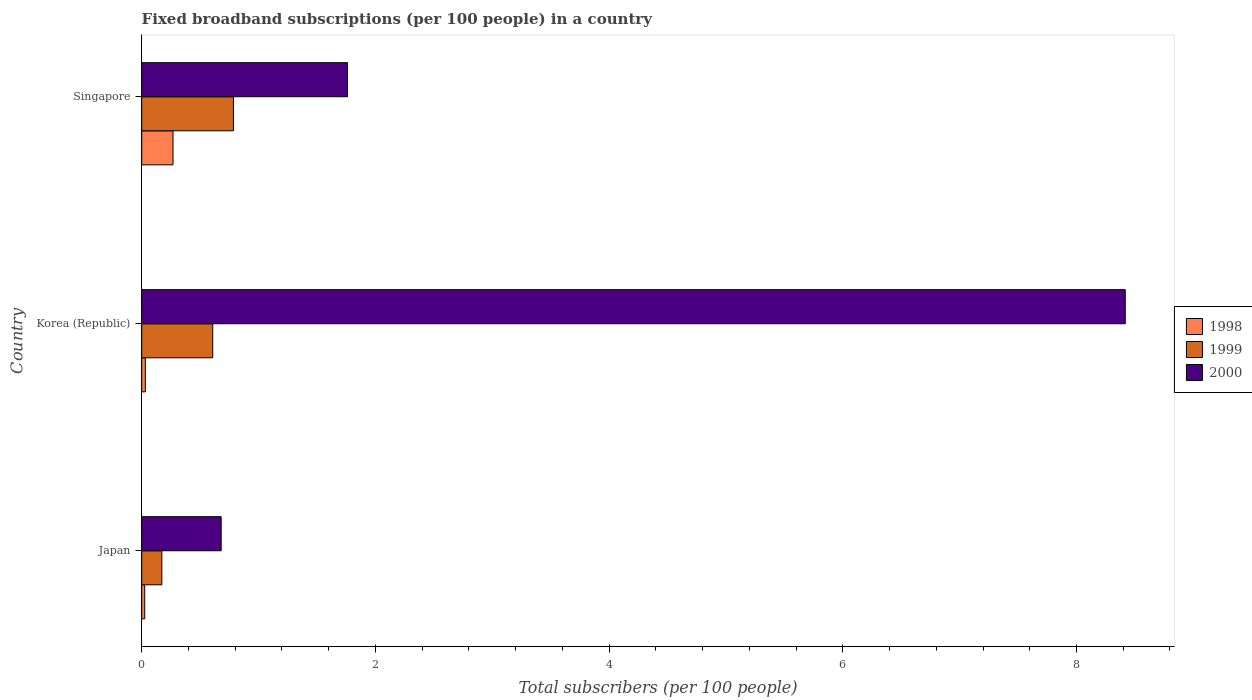How many bars are there on the 3rd tick from the bottom?
Your answer should be very brief. 3. What is the number of broadband subscriptions in 2000 in Japan?
Keep it short and to the point. 0.68. Across all countries, what is the maximum number of broadband subscriptions in 1999?
Your answer should be compact. 0.78. Across all countries, what is the minimum number of broadband subscriptions in 1999?
Make the answer very short. 0.17. In which country was the number of broadband subscriptions in 1998 maximum?
Offer a very short reply. Singapore. In which country was the number of broadband subscriptions in 1999 minimum?
Ensure brevity in your answer.  Japan. What is the total number of broadband subscriptions in 2000 in the graph?
Offer a very short reply. 10.86. What is the difference between the number of broadband subscriptions in 1999 in Korea (Republic) and that in Singapore?
Your response must be concise. -0.18. What is the difference between the number of broadband subscriptions in 2000 in Japan and the number of broadband subscriptions in 1998 in Korea (Republic)?
Give a very brief answer. 0.65. What is the average number of broadband subscriptions in 1999 per country?
Keep it short and to the point. 0.52. What is the difference between the number of broadband subscriptions in 1999 and number of broadband subscriptions in 1998 in Korea (Republic)?
Your answer should be very brief. 0.58. In how many countries, is the number of broadband subscriptions in 1999 greater than 6.8 ?
Your answer should be very brief. 0. What is the ratio of the number of broadband subscriptions in 2000 in Japan to that in Korea (Republic)?
Your answer should be compact. 0.08. Is the number of broadband subscriptions in 1999 in Korea (Republic) less than that in Singapore?
Make the answer very short. Yes. What is the difference between the highest and the second highest number of broadband subscriptions in 1999?
Give a very brief answer. 0.18. What is the difference between the highest and the lowest number of broadband subscriptions in 1998?
Your answer should be very brief. 0.24. Is the sum of the number of broadband subscriptions in 1998 in Korea (Republic) and Singapore greater than the maximum number of broadband subscriptions in 2000 across all countries?
Make the answer very short. No. Is it the case that in every country, the sum of the number of broadband subscriptions in 1999 and number of broadband subscriptions in 1998 is greater than the number of broadband subscriptions in 2000?
Your answer should be compact. No. How many bars are there?
Give a very brief answer. 9. What is the difference between two consecutive major ticks on the X-axis?
Offer a very short reply. 2. Does the graph contain any zero values?
Make the answer very short. No. Does the graph contain grids?
Provide a short and direct response. No. How many legend labels are there?
Your answer should be compact. 3. What is the title of the graph?
Your response must be concise. Fixed broadband subscriptions (per 100 people) in a country. What is the label or title of the X-axis?
Provide a succinct answer. Total subscribers (per 100 people). What is the label or title of the Y-axis?
Provide a succinct answer. Country. What is the Total subscribers (per 100 people) of 1998 in Japan?
Make the answer very short. 0.03. What is the Total subscribers (per 100 people) of 1999 in Japan?
Your response must be concise. 0.17. What is the Total subscribers (per 100 people) of 2000 in Japan?
Ensure brevity in your answer.  0.68. What is the Total subscribers (per 100 people) of 1998 in Korea (Republic)?
Your response must be concise. 0.03. What is the Total subscribers (per 100 people) in 1999 in Korea (Republic)?
Your answer should be very brief. 0.61. What is the Total subscribers (per 100 people) in 2000 in Korea (Republic)?
Give a very brief answer. 8.42. What is the Total subscribers (per 100 people) in 1998 in Singapore?
Give a very brief answer. 0.27. What is the Total subscribers (per 100 people) of 1999 in Singapore?
Your answer should be compact. 0.78. What is the Total subscribers (per 100 people) in 2000 in Singapore?
Keep it short and to the point. 1.76. Across all countries, what is the maximum Total subscribers (per 100 people) in 1998?
Offer a very short reply. 0.27. Across all countries, what is the maximum Total subscribers (per 100 people) in 1999?
Keep it short and to the point. 0.78. Across all countries, what is the maximum Total subscribers (per 100 people) of 2000?
Offer a very short reply. 8.42. Across all countries, what is the minimum Total subscribers (per 100 people) of 1998?
Offer a very short reply. 0.03. Across all countries, what is the minimum Total subscribers (per 100 people) in 1999?
Provide a short and direct response. 0.17. Across all countries, what is the minimum Total subscribers (per 100 people) in 2000?
Offer a terse response. 0.68. What is the total Total subscribers (per 100 people) in 1998 in the graph?
Ensure brevity in your answer.  0.32. What is the total Total subscribers (per 100 people) in 1999 in the graph?
Offer a terse response. 1.56. What is the total Total subscribers (per 100 people) in 2000 in the graph?
Offer a very short reply. 10.86. What is the difference between the Total subscribers (per 100 people) of 1998 in Japan and that in Korea (Republic)?
Give a very brief answer. -0.01. What is the difference between the Total subscribers (per 100 people) of 1999 in Japan and that in Korea (Republic)?
Keep it short and to the point. -0.44. What is the difference between the Total subscribers (per 100 people) in 2000 in Japan and that in Korea (Republic)?
Ensure brevity in your answer.  -7.74. What is the difference between the Total subscribers (per 100 people) in 1998 in Japan and that in Singapore?
Your answer should be very brief. -0.24. What is the difference between the Total subscribers (per 100 people) of 1999 in Japan and that in Singapore?
Provide a short and direct response. -0.61. What is the difference between the Total subscribers (per 100 people) in 2000 in Japan and that in Singapore?
Your answer should be compact. -1.08. What is the difference between the Total subscribers (per 100 people) of 1998 in Korea (Republic) and that in Singapore?
Offer a very short reply. -0.24. What is the difference between the Total subscribers (per 100 people) in 1999 in Korea (Republic) and that in Singapore?
Your answer should be very brief. -0.18. What is the difference between the Total subscribers (per 100 people) of 2000 in Korea (Republic) and that in Singapore?
Your response must be concise. 6.66. What is the difference between the Total subscribers (per 100 people) of 1998 in Japan and the Total subscribers (per 100 people) of 1999 in Korea (Republic)?
Make the answer very short. -0.58. What is the difference between the Total subscribers (per 100 people) in 1998 in Japan and the Total subscribers (per 100 people) in 2000 in Korea (Republic)?
Your response must be concise. -8.39. What is the difference between the Total subscribers (per 100 people) in 1999 in Japan and the Total subscribers (per 100 people) in 2000 in Korea (Republic)?
Make the answer very short. -8.25. What is the difference between the Total subscribers (per 100 people) in 1998 in Japan and the Total subscribers (per 100 people) in 1999 in Singapore?
Give a very brief answer. -0.76. What is the difference between the Total subscribers (per 100 people) of 1998 in Japan and the Total subscribers (per 100 people) of 2000 in Singapore?
Give a very brief answer. -1.74. What is the difference between the Total subscribers (per 100 people) in 1999 in Japan and the Total subscribers (per 100 people) in 2000 in Singapore?
Ensure brevity in your answer.  -1.59. What is the difference between the Total subscribers (per 100 people) in 1998 in Korea (Republic) and the Total subscribers (per 100 people) in 1999 in Singapore?
Your answer should be very brief. -0.75. What is the difference between the Total subscribers (per 100 people) in 1998 in Korea (Republic) and the Total subscribers (per 100 people) in 2000 in Singapore?
Provide a succinct answer. -1.73. What is the difference between the Total subscribers (per 100 people) in 1999 in Korea (Republic) and the Total subscribers (per 100 people) in 2000 in Singapore?
Make the answer very short. -1.15. What is the average Total subscribers (per 100 people) of 1998 per country?
Offer a terse response. 0.11. What is the average Total subscribers (per 100 people) of 1999 per country?
Make the answer very short. 0.52. What is the average Total subscribers (per 100 people) of 2000 per country?
Your answer should be compact. 3.62. What is the difference between the Total subscribers (per 100 people) in 1998 and Total subscribers (per 100 people) in 1999 in Japan?
Your response must be concise. -0.15. What is the difference between the Total subscribers (per 100 people) in 1998 and Total subscribers (per 100 people) in 2000 in Japan?
Your response must be concise. -0.65. What is the difference between the Total subscribers (per 100 people) of 1999 and Total subscribers (per 100 people) of 2000 in Japan?
Offer a terse response. -0.51. What is the difference between the Total subscribers (per 100 people) in 1998 and Total subscribers (per 100 people) in 1999 in Korea (Republic)?
Your answer should be compact. -0.58. What is the difference between the Total subscribers (per 100 people) in 1998 and Total subscribers (per 100 people) in 2000 in Korea (Republic)?
Your answer should be very brief. -8.39. What is the difference between the Total subscribers (per 100 people) in 1999 and Total subscribers (per 100 people) in 2000 in Korea (Republic)?
Give a very brief answer. -7.81. What is the difference between the Total subscribers (per 100 people) in 1998 and Total subscribers (per 100 people) in 1999 in Singapore?
Provide a short and direct response. -0.52. What is the difference between the Total subscribers (per 100 people) of 1998 and Total subscribers (per 100 people) of 2000 in Singapore?
Your answer should be compact. -1.49. What is the difference between the Total subscribers (per 100 people) in 1999 and Total subscribers (per 100 people) in 2000 in Singapore?
Keep it short and to the point. -0.98. What is the ratio of the Total subscribers (per 100 people) of 1998 in Japan to that in Korea (Republic)?
Offer a very short reply. 0.83. What is the ratio of the Total subscribers (per 100 people) of 1999 in Japan to that in Korea (Republic)?
Make the answer very short. 0.28. What is the ratio of the Total subscribers (per 100 people) in 2000 in Japan to that in Korea (Republic)?
Offer a terse response. 0.08. What is the ratio of the Total subscribers (per 100 people) of 1998 in Japan to that in Singapore?
Ensure brevity in your answer.  0.1. What is the ratio of the Total subscribers (per 100 people) in 1999 in Japan to that in Singapore?
Give a very brief answer. 0.22. What is the ratio of the Total subscribers (per 100 people) of 2000 in Japan to that in Singapore?
Ensure brevity in your answer.  0.39. What is the ratio of the Total subscribers (per 100 people) of 1998 in Korea (Republic) to that in Singapore?
Ensure brevity in your answer.  0.12. What is the ratio of the Total subscribers (per 100 people) of 1999 in Korea (Republic) to that in Singapore?
Offer a terse response. 0.77. What is the ratio of the Total subscribers (per 100 people) of 2000 in Korea (Republic) to that in Singapore?
Offer a terse response. 4.78. What is the difference between the highest and the second highest Total subscribers (per 100 people) of 1998?
Offer a very short reply. 0.24. What is the difference between the highest and the second highest Total subscribers (per 100 people) of 1999?
Your response must be concise. 0.18. What is the difference between the highest and the second highest Total subscribers (per 100 people) in 2000?
Offer a very short reply. 6.66. What is the difference between the highest and the lowest Total subscribers (per 100 people) of 1998?
Keep it short and to the point. 0.24. What is the difference between the highest and the lowest Total subscribers (per 100 people) in 1999?
Offer a very short reply. 0.61. What is the difference between the highest and the lowest Total subscribers (per 100 people) in 2000?
Offer a very short reply. 7.74. 